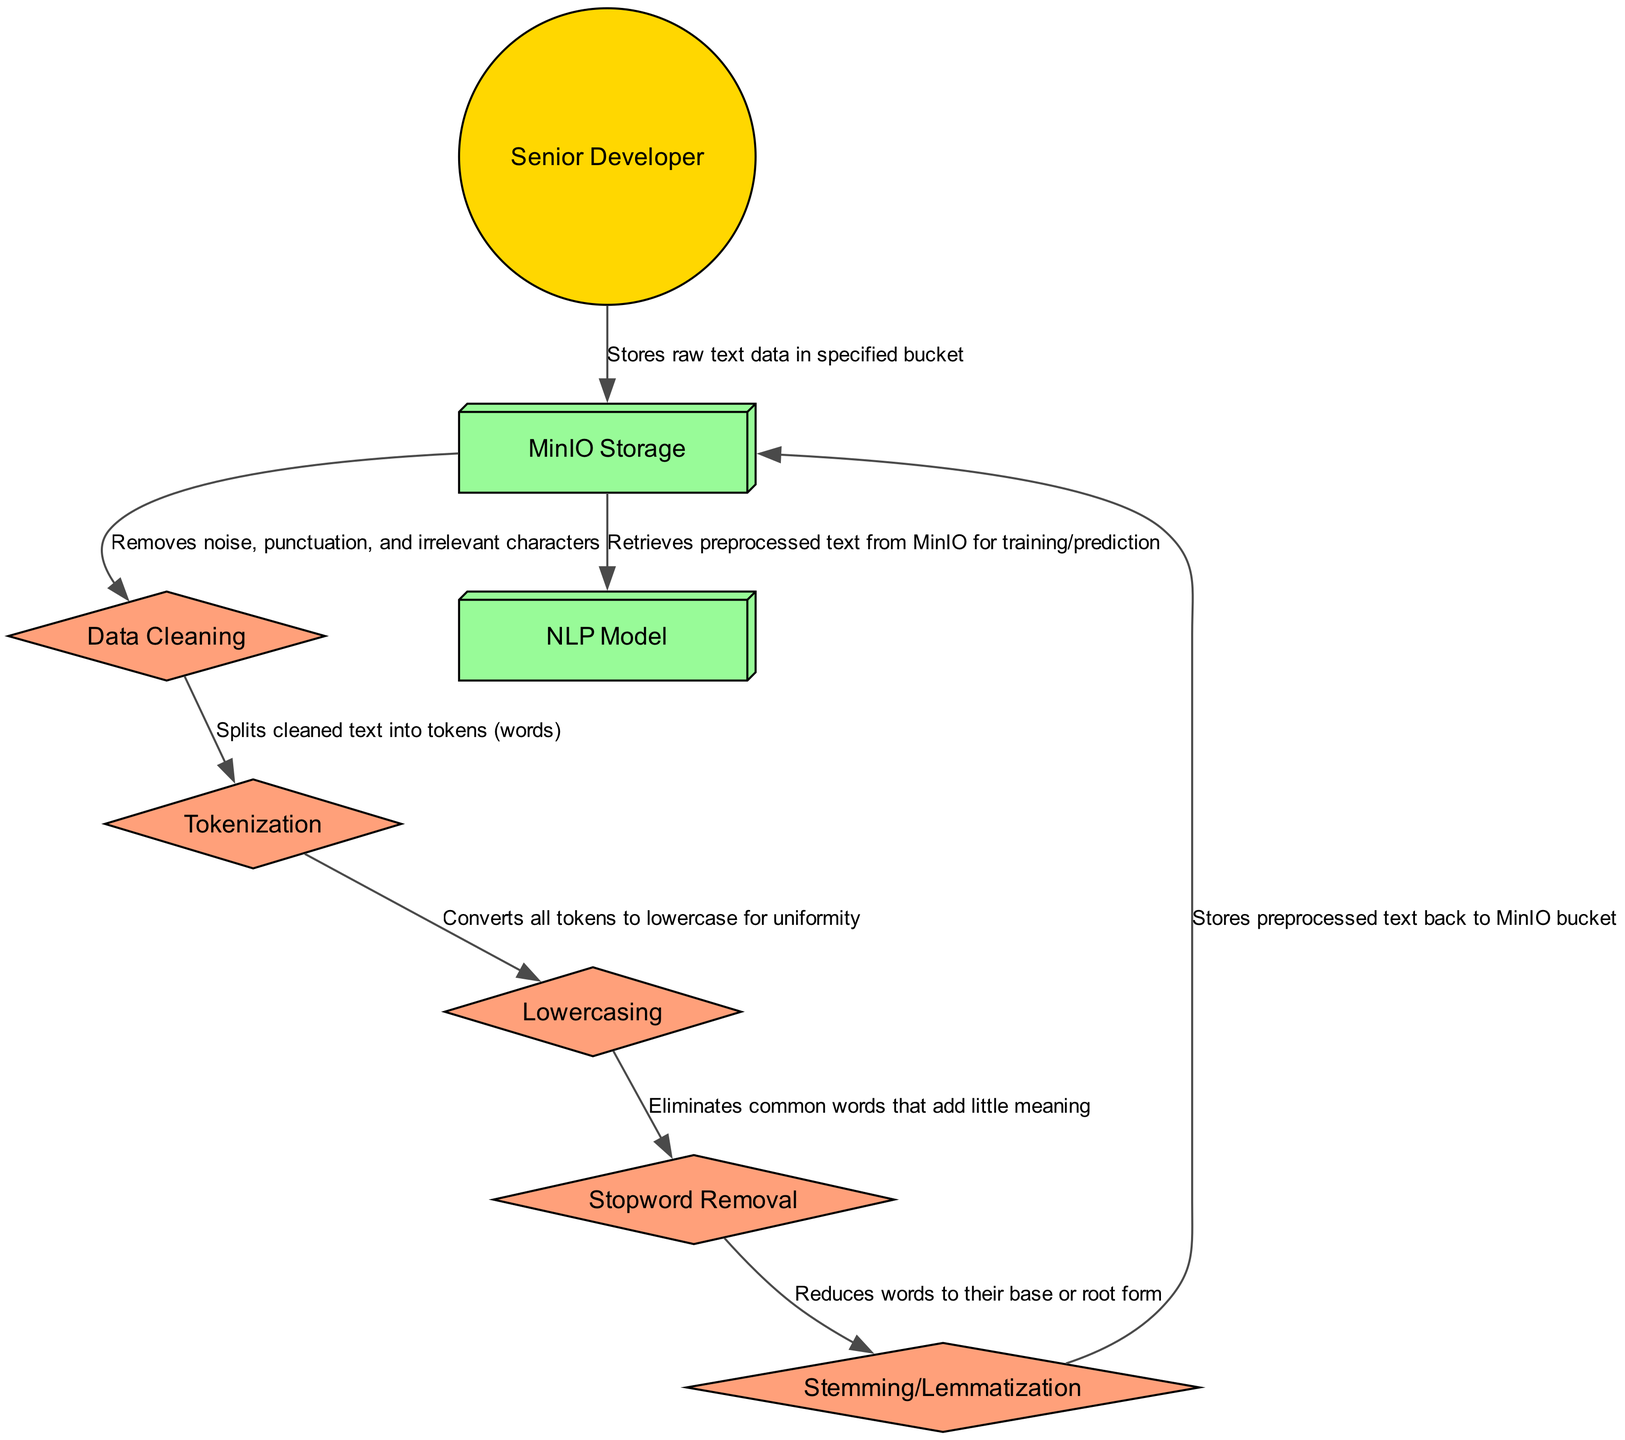What is the first action performed in the sequence? The first action listed under the "actor" category is "Uploads raw text data to MinIO bucket" by the Senior Developer.
Answer: Uploads raw text data to MinIO bucket How many processes are represented in the diagram? There are five processes specified in the diagram, which include Data Cleaning, Tokenization, Lowercasing, Stopword Removal, and Stemming/Lemmatization.
Answer: Five Which component stores the preprocessed text? The last action before the NLP Model retrieves text states that "Stores preprocessed text back to MinIO bucket," indicating that the preprocessed text is stored back in the MinIO Storage system.
Answer: MinIO Storage What action follows the Tokenization process? After the Tokenization process, the next action is "Lowercasing," which converts all tokens to lowercase for uniformity.
Answer: Lowercasing Which two systems are involved in this sequence? There are two systems indicated: "MinIO Storage" and "NLP Model," which shows the interaction of components involved in data storage and processing.
Answer: MinIO Storage, NLP Model What does the Data Cleaning process remove? The action associated with Data Cleaning mentions that it "Removes noise, punctuation, and irrelevant characters," indicating the specific elements it addresses.
Answer: Noise, punctuation, and irrelevant characters What is the last step taken in the sequence before data is used for model training? The last interaction is where the "NLP Model" retrieves the preprocessed text from the MinIO Storage for training or prediction, marking the final step before model usage.
Answer: Retrieves preprocessed text from MinIO Which action is performed to simplify the text after Stopword Removal? The action following Stopword Removal is "Stemming/Lemmatization," which reduces words to their base or root form.
Answer: Stemming/Lemmatization How does the diagram represent the Senior Developer? The Senior Developer is depicted as an 'actor' in the diagram, represented visually by a circle filled with a golden color (FFD700).
Answer: Circle filled with golden color 